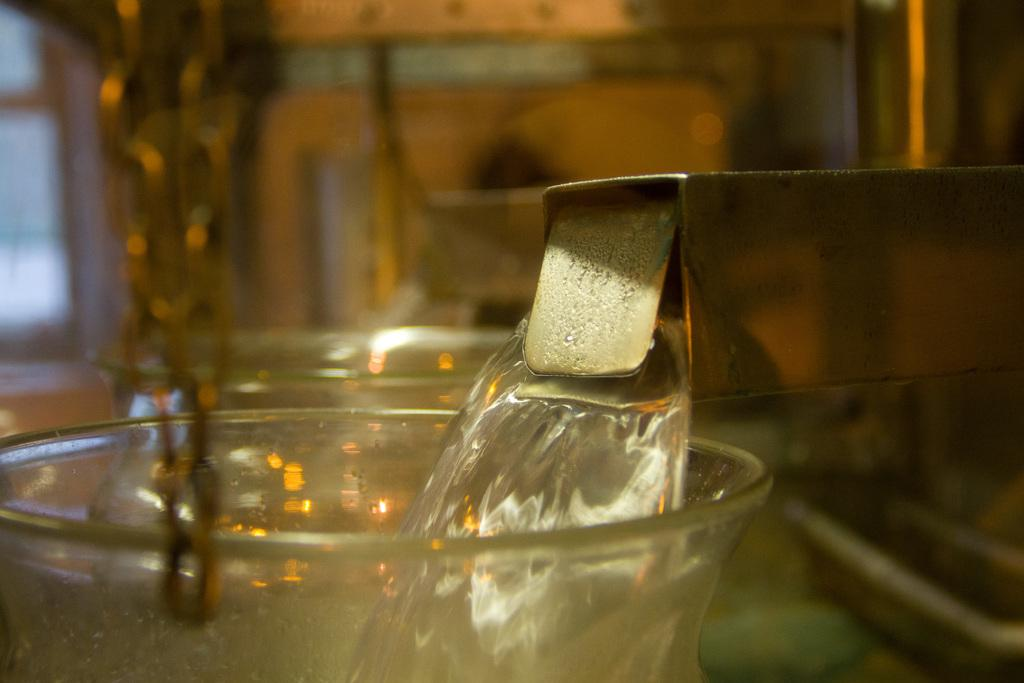What object can be seen in the image that is typically used for holding liquids? There is a glass tumbler in the image. What is inside the glass tumbler? There is a beverage in the image. How does the glass tumbler receive approval from the beverage? The glass tumbler does not receive approval from the beverage, as it is an inanimate object and cannot receive approval. 